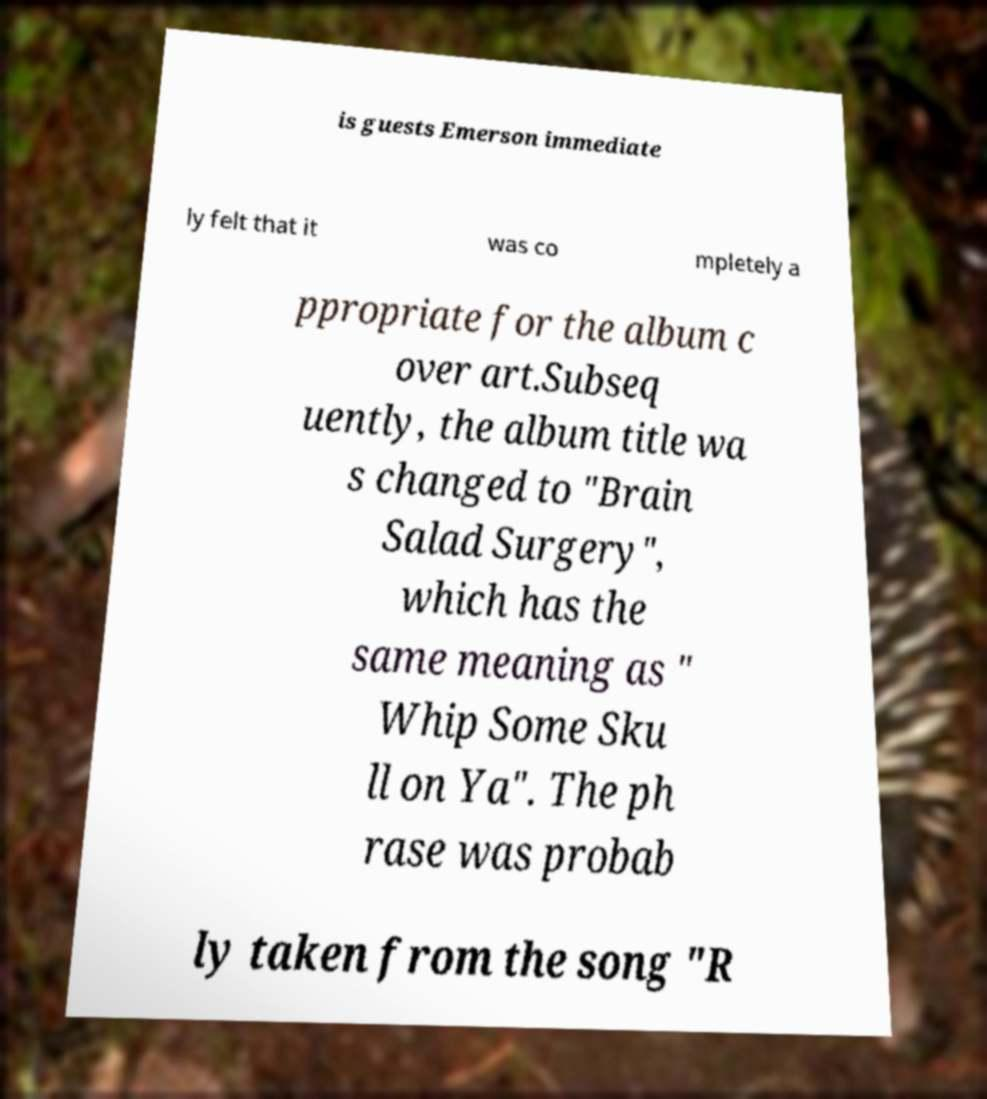There's text embedded in this image that I need extracted. Can you transcribe it verbatim? is guests Emerson immediate ly felt that it was co mpletely a ppropriate for the album c over art.Subseq uently, the album title wa s changed to "Brain Salad Surgery", which has the same meaning as " Whip Some Sku ll on Ya". The ph rase was probab ly taken from the song "R 